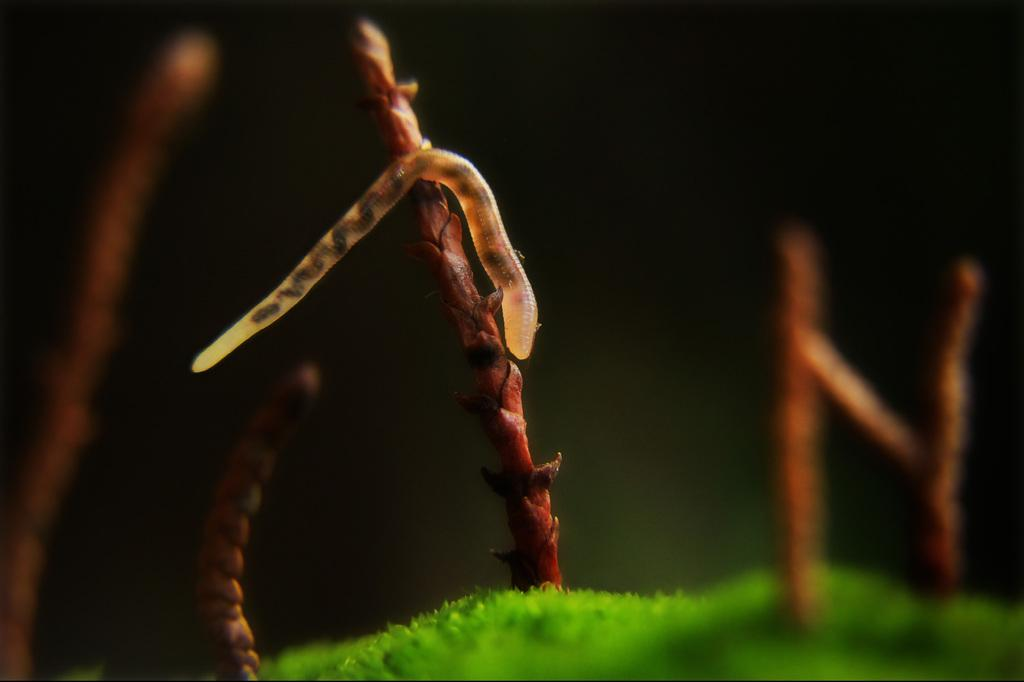What type of vegetation is present in the image? There is grass in the image. What can be seen above the grass? There are stems above the grass. Is there any living organism visible on the grass or stems? Yes, there is a worm on the system (which could refer to the stems or grass). What type of creature is seen playing during recess in the image? There is no recess or creature playing in the image; it features grass, stems, and a worm. 